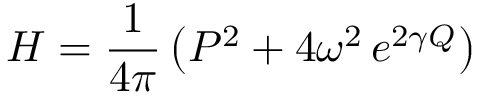<formula> <loc_0><loc_0><loc_500><loc_500>H = \frac { 1 } { 4 \pi } \left ( P ^ { 2 } + 4 \omega ^ { 2 } \, e ^ { 2 \gamma Q } \right )</formula> 